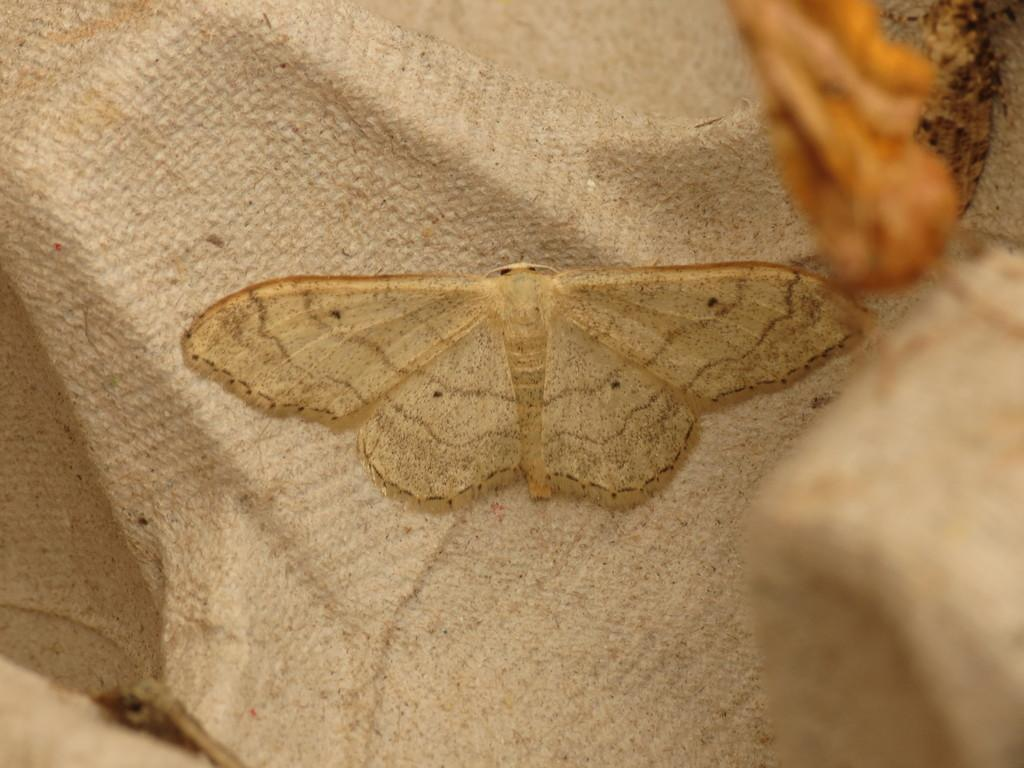What is the main subject of the image? There is a butterfly in the image. Can you describe the color of the butterfly? The butterfly is cream-colored. What is the butterfly sitting on in the image? The butterfly is sitting on a cloth. What type of reaction does the butterfly have to the baseball in the image? There is no baseball present in the image, so the butterfly cannot have a reaction to it. 